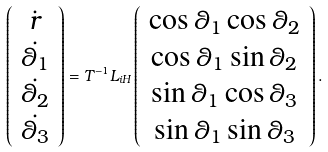<formula> <loc_0><loc_0><loc_500><loc_500>\left ( \begin{array} { c } \dot { r } \\ \dot { \theta _ { 1 } } \\ \dot { \theta _ { 2 } } \\ \dot { \theta _ { 3 } } \end{array} \right ) = T ^ { - 1 } L _ { i H } \left ( \begin{array} { c } \cos \theta _ { 1 } \cos \theta _ { 2 } \\ \cos \theta _ { 1 } \sin \theta _ { 2 } \\ \sin \theta _ { 1 } \cos \theta _ { 3 } \\ \sin \theta _ { 1 } \sin \theta _ { 3 } \\ \end{array} \right ) .</formula> 